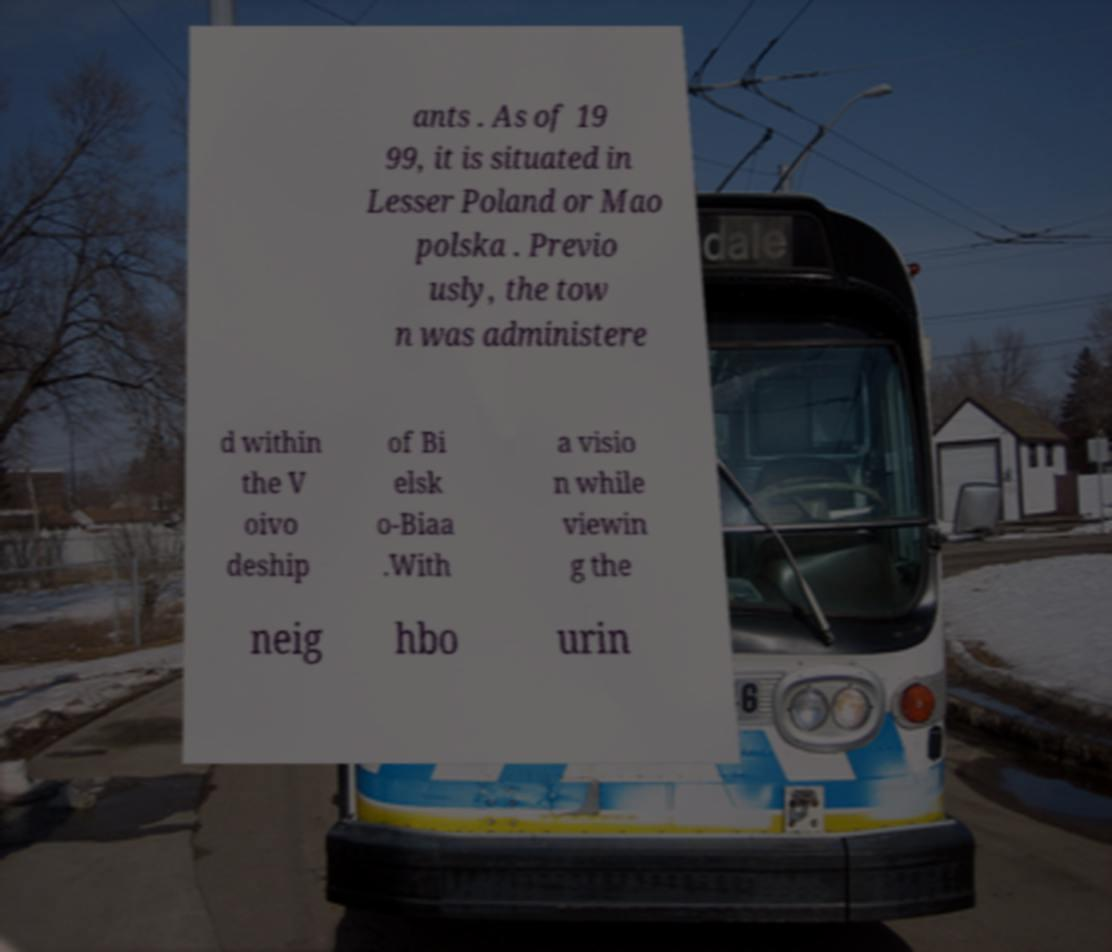Can you read and provide the text displayed in the image?This photo seems to have some interesting text. Can you extract and type it out for me? ants . As of 19 99, it is situated in Lesser Poland or Mao polska . Previo usly, the tow n was administere d within the V oivo deship of Bi elsk o-Biaa .With a visio n while viewin g the neig hbo urin 